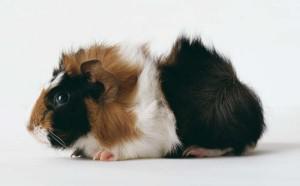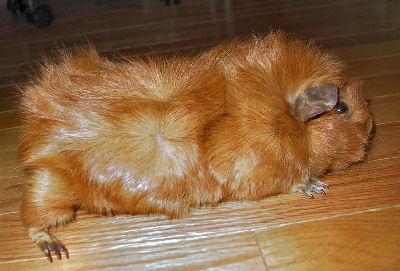The first image is the image on the left, the second image is the image on the right. Examine the images to the left and right. Is the description "Each image contains a single guinea pig, and the one on the right has all golden-orange fur." accurate? Answer yes or no. Yes. The first image is the image on the left, the second image is the image on the right. Examine the images to the left and right. Is the description "There are two hamsters lying down." accurate? Answer yes or no. No. 